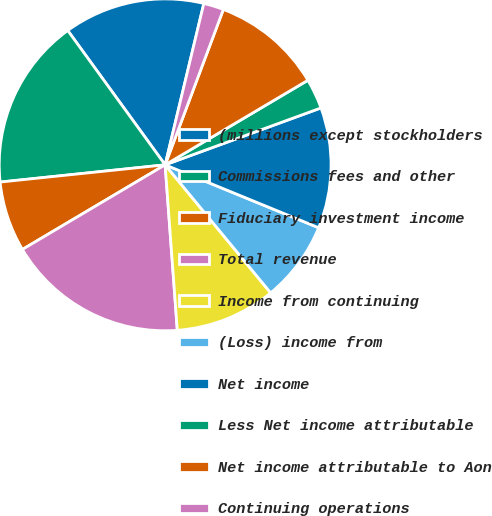Convert chart. <chart><loc_0><loc_0><loc_500><loc_500><pie_chart><fcel>(millions except stockholders<fcel>Commissions fees and other<fcel>Fiduciary investment income<fcel>Total revenue<fcel>Income from continuing<fcel>(Loss) income from<fcel>Net income<fcel>Less Net income attributable<fcel>Net income attributable to Aon<fcel>Continuing operations<nl><fcel>13.73%<fcel>16.67%<fcel>6.86%<fcel>17.65%<fcel>9.8%<fcel>7.84%<fcel>11.76%<fcel>2.94%<fcel>10.78%<fcel>1.96%<nl></chart> 